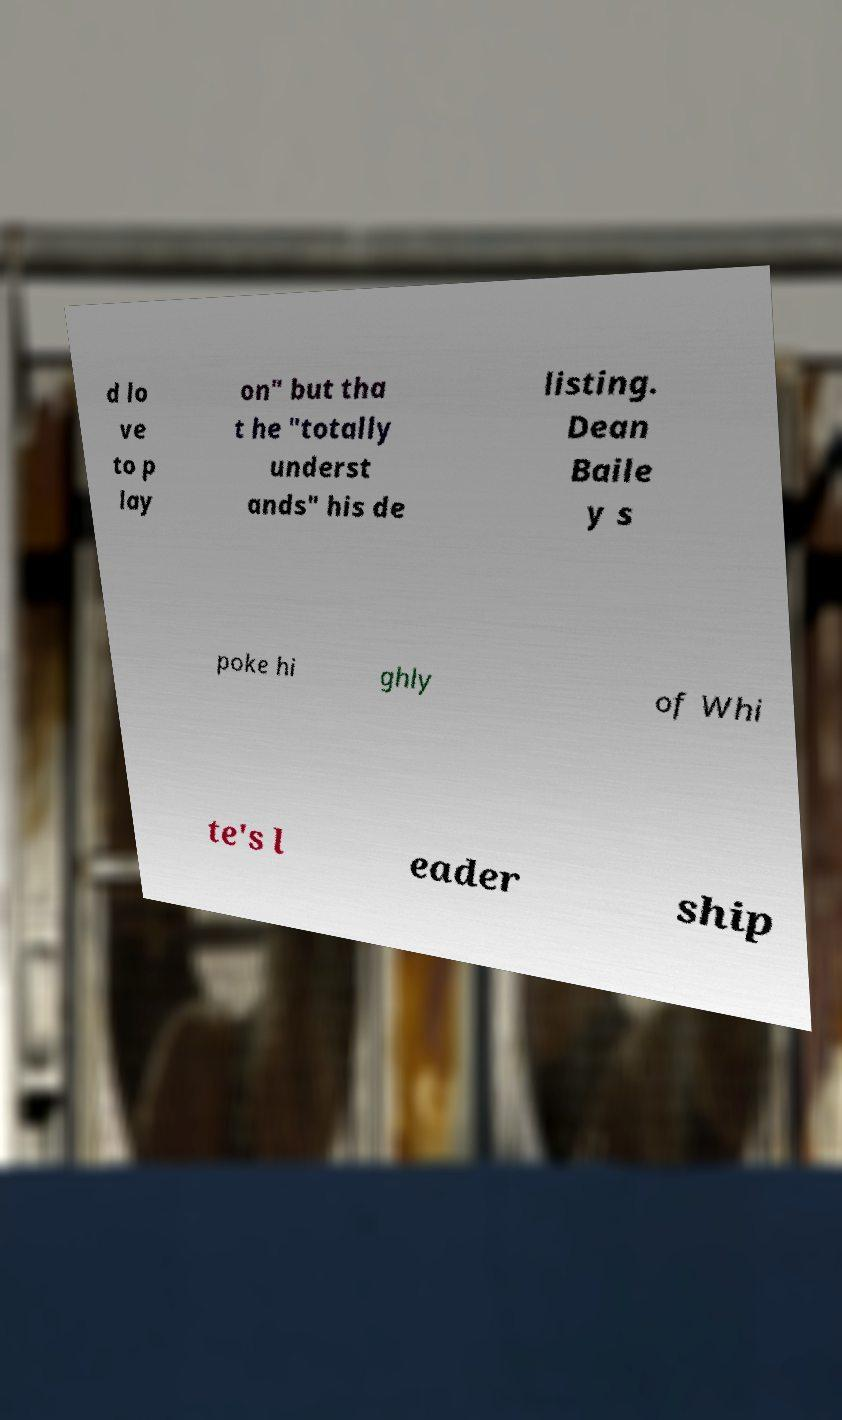Can you accurately transcribe the text from the provided image for me? d lo ve to p lay on" but tha t he "totally underst ands" his de listing. Dean Baile y s poke hi ghly of Whi te's l eader ship 